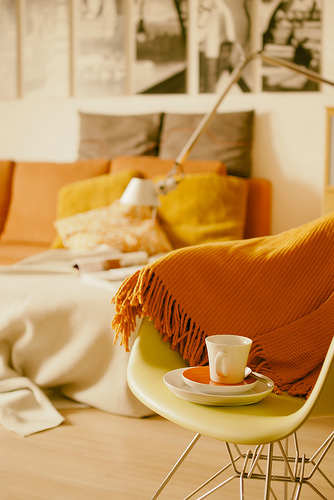<image>
Can you confirm if the cup is on the chair? Yes. Looking at the image, I can see the cup is positioned on top of the chair, with the chair providing support. 